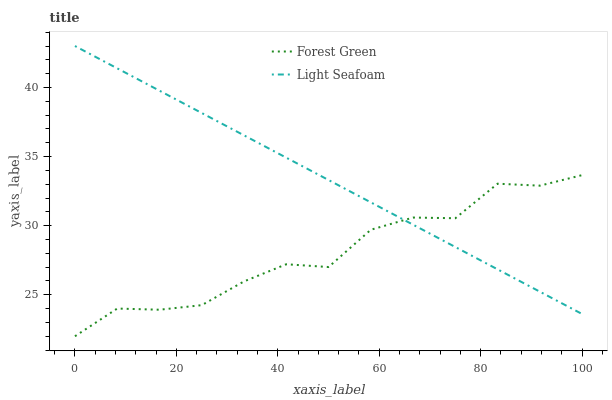Does Light Seafoam have the minimum area under the curve?
Answer yes or no. No. Is Light Seafoam the roughest?
Answer yes or no. No. Does Light Seafoam have the lowest value?
Answer yes or no. No. 